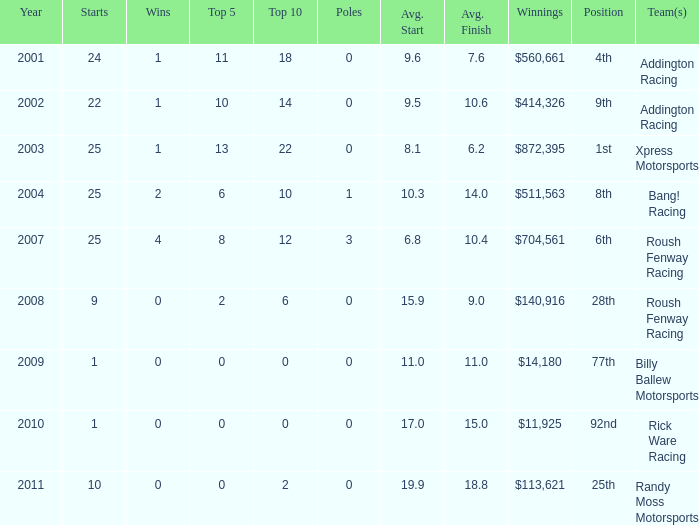What team or teams with 18 in the top 10? Addington Racing. 